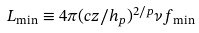Convert formula to latex. <formula><loc_0><loc_0><loc_500><loc_500>L _ { \min } \equiv 4 \pi ( c z / h _ { p } ) ^ { 2 / p } \nu f _ { \min }</formula> 